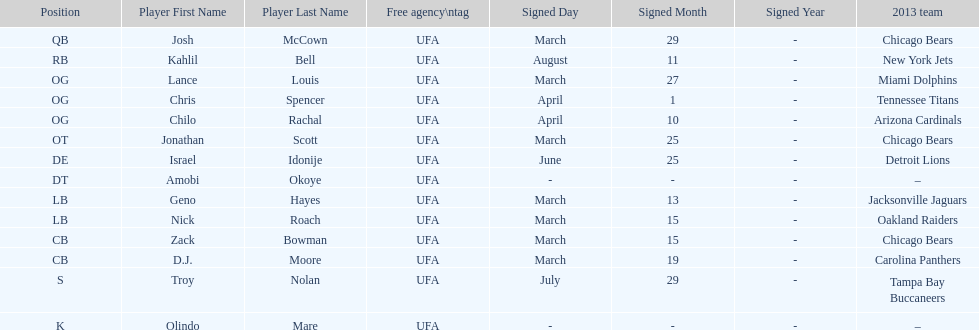The only player to sign in july? Troy Nolan. 